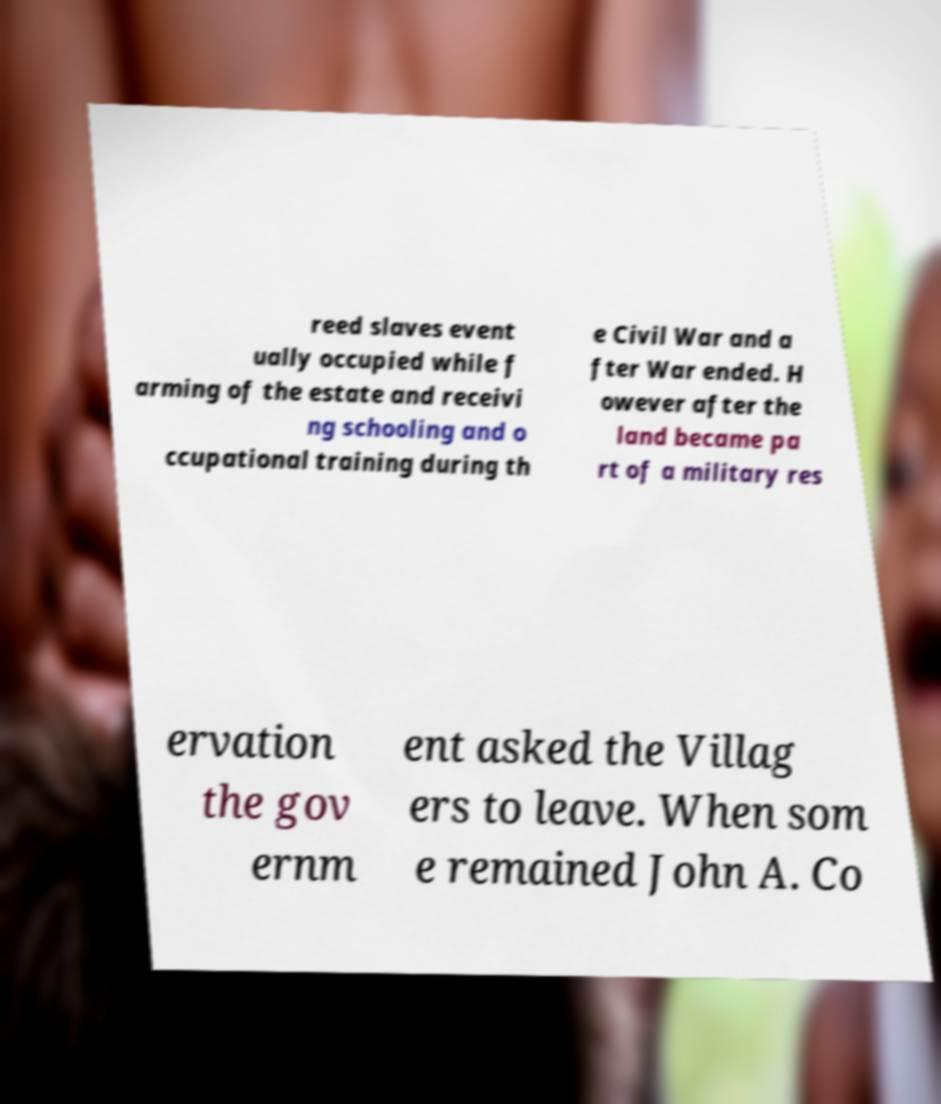Please identify and transcribe the text found in this image. reed slaves event ually occupied while f arming of the estate and receivi ng schooling and o ccupational training during th e Civil War and a fter War ended. H owever after the land became pa rt of a military res ervation the gov ernm ent asked the Villag ers to leave. When som e remained John A. Co 